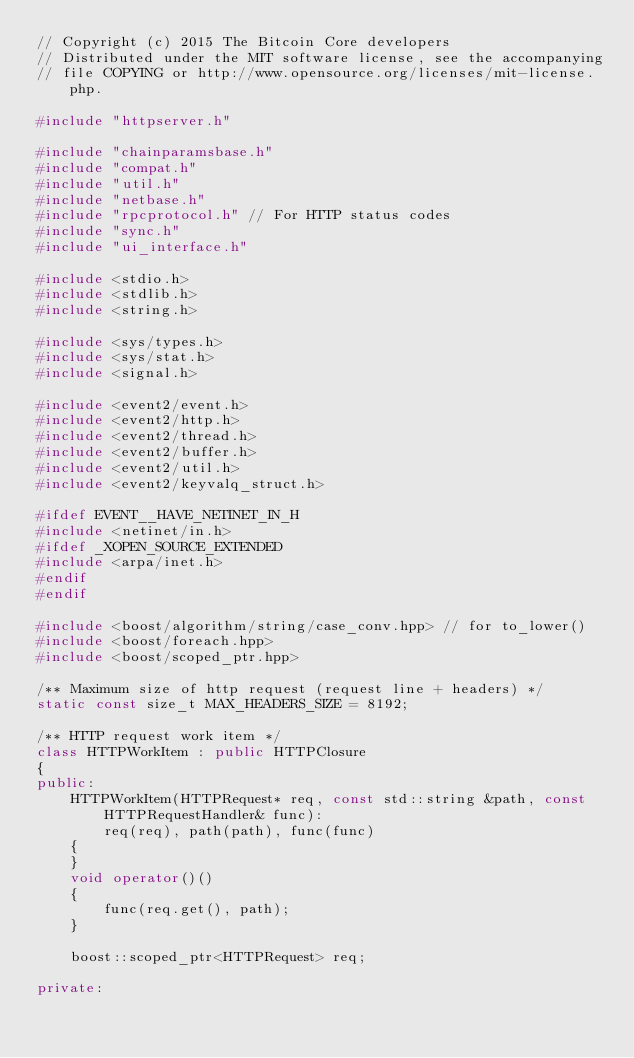Convert code to text. <code><loc_0><loc_0><loc_500><loc_500><_C++_>// Copyright (c) 2015 The Bitcoin Core developers
// Distributed under the MIT software license, see the accompanying
// file COPYING or http://www.opensource.org/licenses/mit-license.php.

#include "httpserver.h"

#include "chainparamsbase.h"
#include "compat.h"
#include "util.h"
#include "netbase.h"
#include "rpcprotocol.h" // For HTTP status codes
#include "sync.h"
#include "ui_interface.h"

#include <stdio.h>
#include <stdlib.h>
#include <string.h>

#include <sys/types.h>
#include <sys/stat.h>
#include <signal.h>

#include <event2/event.h>
#include <event2/http.h>
#include <event2/thread.h>
#include <event2/buffer.h>
#include <event2/util.h>
#include <event2/keyvalq_struct.h>

#ifdef EVENT__HAVE_NETINET_IN_H
#include <netinet/in.h>
#ifdef _XOPEN_SOURCE_EXTENDED
#include <arpa/inet.h>
#endif
#endif

#include <boost/algorithm/string/case_conv.hpp> // for to_lower()
#include <boost/foreach.hpp>
#include <boost/scoped_ptr.hpp>

/** Maximum size of http request (request line + headers) */
static const size_t MAX_HEADERS_SIZE = 8192;

/** HTTP request work item */
class HTTPWorkItem : public HTTPClosure
{
public:
    HTTPWorkItem(HTTPRequest* req, const std::string &path, const HTTPRequestHandler& func):
        req(req), path(path), func(func)
    {
    }
    void operator()()
    {
        func(req.get(), path);
    }

    boost::scoped_ptr<HTTPRequest> req;

private:</code> 